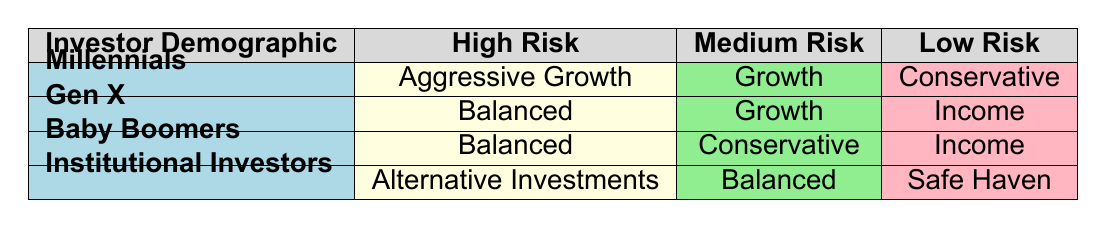What asset allocation strategy do Millennials use for high risk tolerance? According to the table, Millennials have chosen "Aggressive Growth" as their asset allocation strategy for high risk tolerance.
Answer: Aggressive Growth Which asset allocation strategy is most associated with low risk tolerance among Gen X? Looking at the table, the asset allocation strategy associated with low risk tolerance for Gen X is "Income."
Answer: Income True or False: Baby Boomers with a medium risk tolerance have an aggressive growth strategy. The table indicates that Baby Boomers with a medium risk tolerance use a "Conservative" strategy, not aggressive growth. Therefore, the statement is false.
Answer: False What is the overall trend for asset allocation strategy among high-risk tolerant investors? From the table, high-risk tolerant investors (Millennials, Gen X, Baby Boomers, and Institutional Investors) have chosen varying strategies: "Aggressive Growth," "Balanced," and "Alternative Investments." This suggests a trend toward more aggressive strategies.
Answer: Varying strategies What is the average number of asset allocation strategies used by different investor demographics across all risk tolerance levels? There are four investor demographics and three risk tolerance levels, leading to a total of 12 entries (4 demographics x 3 risk levels). Each demographic has a specific strategy linked to their risk tolerance, resulting in 1 strategy per risk level. The average is therefore 1.
Answer: 1 